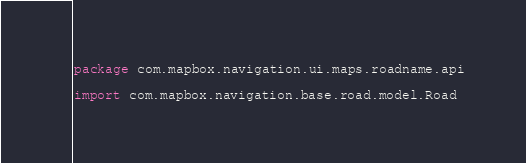Convert code to text. <code><loc_0><loc_0><loc_500><loc_500><_Kotlin_>package com.mapbox.navigation.ui.maps.roadname.api

import com.mapbox.navigation.base.road.model.Road</code> 